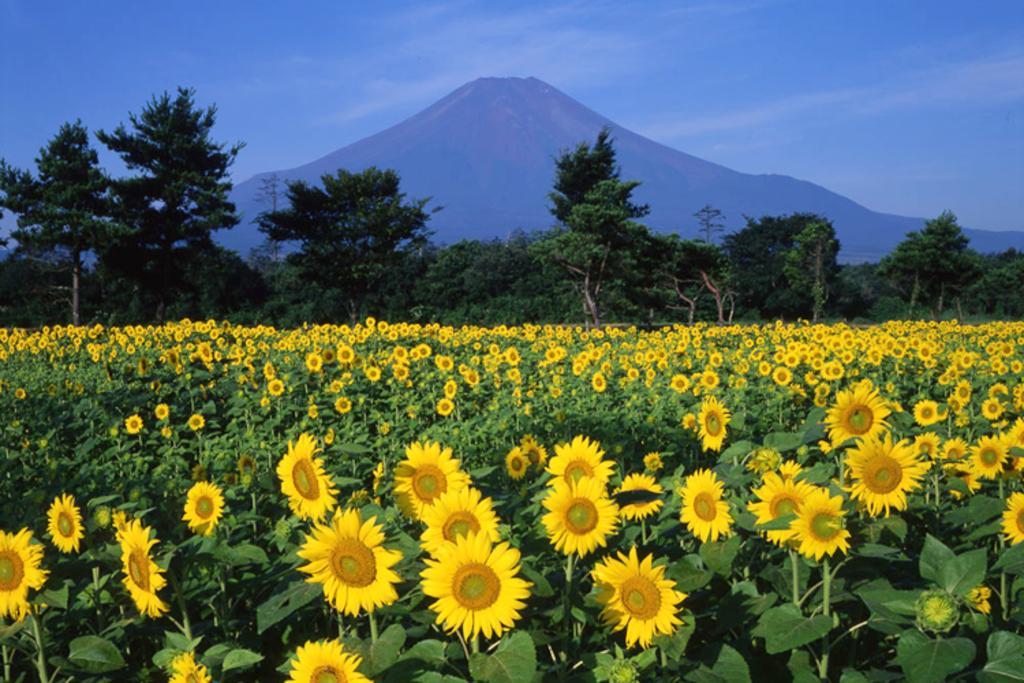Can you describe this image briefly? In this image, I can see the trees and sunflower plants. In the background, there is a hill and the sky. 